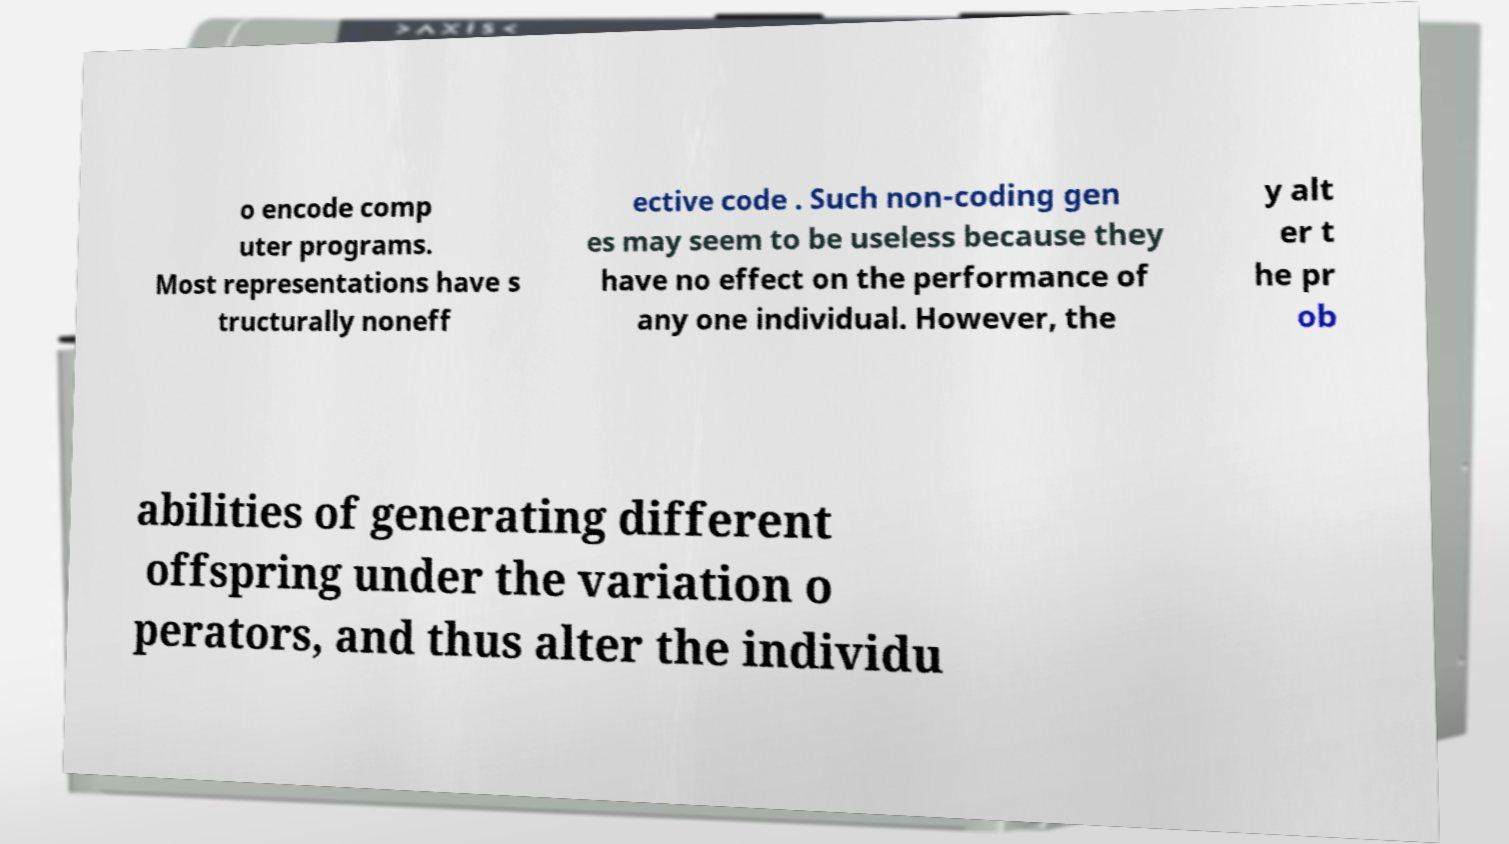There's text embedded in this image that I need extracted. Can you transcribe it verbatim? o encode comp uter programs. Most representations have s tructurally noneff ective code . Such non-coding gen es may seem to be useless because they have no effect on the performance of any one individual. However, the y alt er t he pr ob abilities of generating different offspring under the variation o perators, and thus alter the individu 